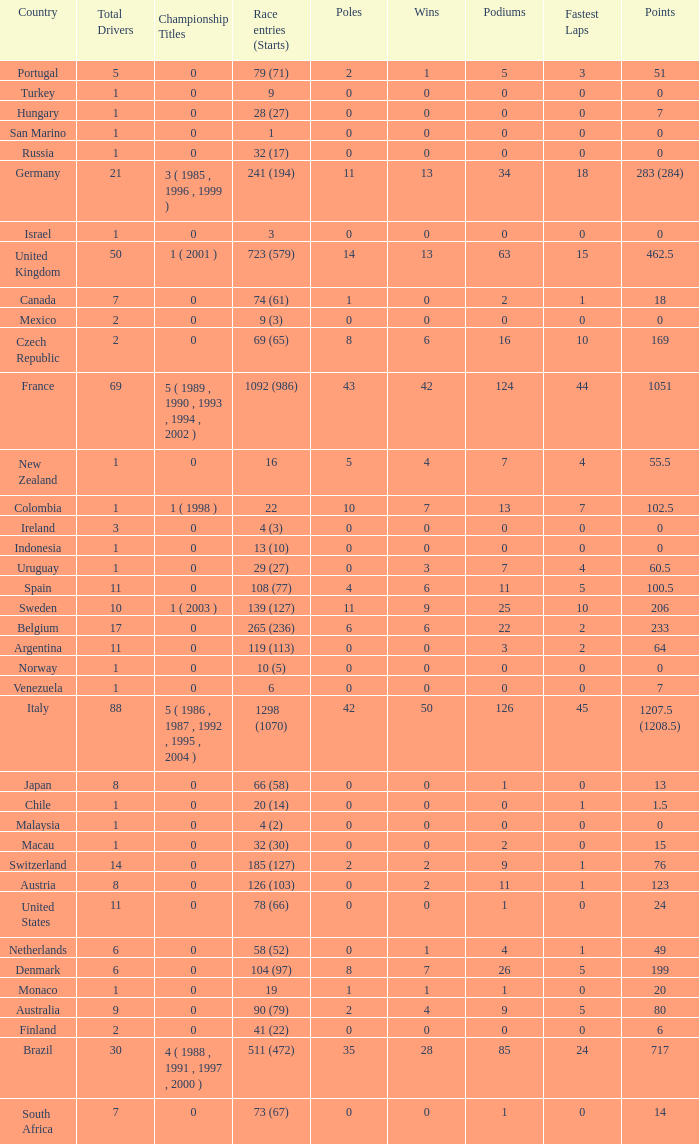How many titles for the nation with less than 3 fastest laps and 22 podiums? 0.0. Could you parse the entire table? {'header': ['Country', 'Total Drivers', 'Championship Titles', 'Race entries (Starts)', 'Poles', 'Wins', 'Podiums', 'Fastest Laps', 'Points'], 'rows': [['Portugal', '5', '0', '79 (71)', '2', '1', '5', '3', '51'], ['Turkey', '1', '0', '9', '0', '0', '0', '0', '0'], ['Hungary', '1', '0', '28 (27)', '0', '0', '0', '0', '7'], ['San Marino', '1', '0', '1', '0', '0', '0', '0', '0'], ['Russia', '1', '0', '32 (17)', '0', '0', '0', '0', '0'], ['Germany', '21', '3 ( 1985 , 1996 , 1999 )', '241 (194)', '11', '13', '34', '18', '283 (284)'], ['Israel', '1', '0', '3', '0', '0', '0', '0', '0'], ['United Kingdom', '50', '1 ( 2001 )', '723 (579)', '14', '13', '63', '15', '462.5'], ['Canada', '7', '0', '74 (61)', '1', '0', '2', '1', '18'], ['Mexico', '2', '0', '9 (3)', '0', '0', '0', '0', '0'], ['Czech Republic', '2', '0', '69 (65)', '8', '6', '16', '10', '169'], ['France', '69', '5 ( 1989 , 1990 , 1993 , 1994 , 2002 )', '1092 (986)', '43', '42', '124', '44', '1051'], ['New Zealand', '1', '0', '16', '5', '4', '7', '4', '55.5'], ['Colombia', '1', '1 ( 1998 )', '22', '10', '7', '13', '7', '102.5'], ['Ireland', '3', '0', '4 (3)', '0', '0', '0', '0', '0'], ['Indonesia', '1', '0', '13 (10)', '0', '0', '0', '0', '0'], ['Uruguay', '1', '0', '29 (27)', '0', '3', '7', '4', '60.5'], ['Spain', '11', '0', '108 (77)', '4', '6', '11', '5', '100.5'], ['Sweden', '10', '1 ( 2003 )', '139 (127)', '11', '9', '25', '10', '206'], ['Belgium', '17', '0', '265 (236)', '6', '6', '22', '2', '233'], ['Argentina', '11', '0', '119 (113)', '0', '0', '3', '2', '64'], ['Norway', '1', '0', '10 (5)', '0', '0', '0', '0', '0'], ['Venezuela', '1', '0', '6', '0', '0', '0', '0', '7'], ['Italy', '88', '5 ( 1986 , 1987 , 1992 , 1995 , 2004 )', '1298 (1070)', '42', '50', '126', '45', '1207.5 (1208.5)'], ['Japan', '8', '0', '66 (58)', '0', '0', '1', '0', '13'], ['Chile', '1', '0', '20 (14)', '0', '0', '0', '1', '1.5'], ['Malaysia', '1', '0', '4 (2)', '0', '0', '0', '0', '0'], ['Macau', '1', '0', '32 (30)', '0', '0', '2', '0', '15'], ['Switzerland', '14', '0', '185 (127)', '2', '2', '9', '1', '76'], ['Austria', '8', '0', '126 (103)', '0', '2', '11', '1', '123'], ['United States', '11', '0', '78 (66)', '0', '0', '1', '0', '24'], ['Netherlands', '6', '0', '58 (52)', '0', '1', '4', '1', '49'], ['Denmark', '6', '0', '104 (97)', '8', '7', '26', '5', '199'], ['Monaco', '1', '0', '19', '1', '1', '1', '0', '20'], ['Australia', '9', '0', '90 (79)', '2', '4', '9', '5', '80'], ['Finland', '2', '0', '41 (22)', '0', '0', '0', '0', '6'], ['Brazil', '30', '4 ( 1988 , 1991 , 1997 , 2000 )', '511 (472)', '35', '28', '85', '24', '717'], ['South Africa', '7', '0', '73 (67)', '0', '0', '1', '0', '14']]} 